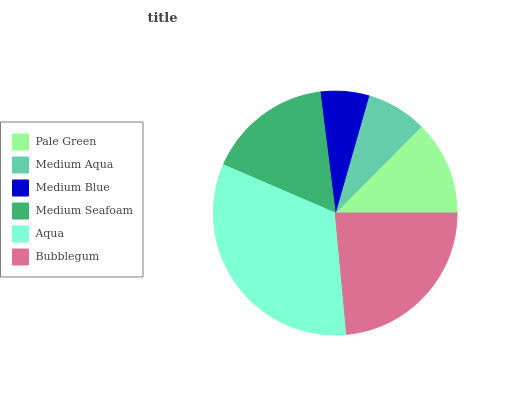Is Medium Blue the minimum?
Answer yes or no. Yes. Is Aqua the maximum?
Answer yes or no. Yes. Is Medium Aqua the minimum?
Answer yes or no. No. Is Medium Aqua the maximum?
Answer yes or no. No. Is Pale Green greater than Medium Aqua?
Answer yes or no. Yes. Is Medium Aqua less than Pale Green?
Answer yes or no. Yes. Is Medium Aqua greater than Pale Green?
Answer yes or no. No. Is Pale Green less than Medium Aqua?
Answer yes or no. No. Is Medium Seafoam the high median?
Answer yes or no. Yes. Is Pale Green the low median?
Answer yes or no. Yes. Is Medium Aqua the high median?
Answer yes or no. No. Is Bubblegum the low median?
Answer yes or no. No. 